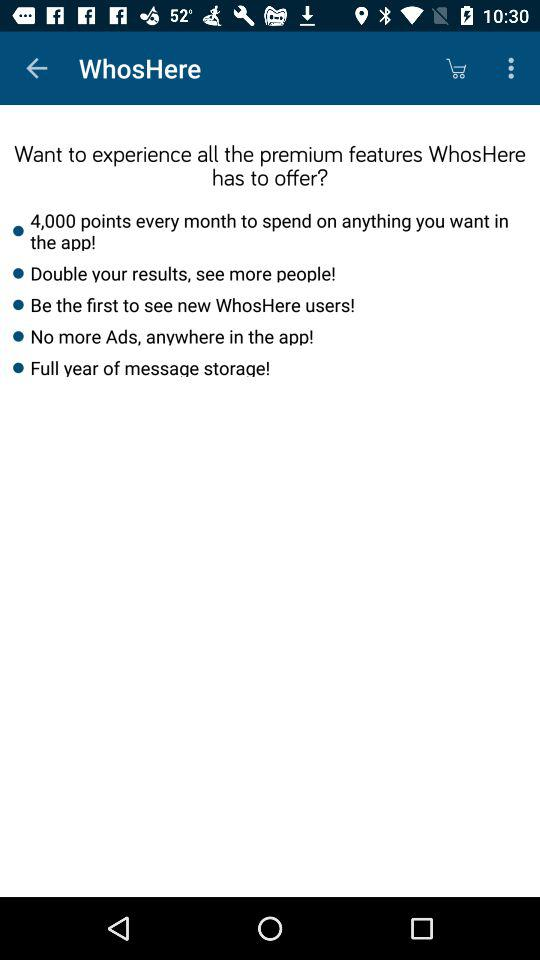Are these premium features common in similar types of apps? Yes, many social networking and dating apps offer analogous premium features. Points or credit systems are commonly used for in-app purchases or activities. Features like seeing more profiles, getting a head start on connecting with new members, and removing ads are pretty standard perks for paid memberships. Extended message storage, however, varies more between services. Some might offer unlimited storage as a base feature, while others might reserve it for premium users. 